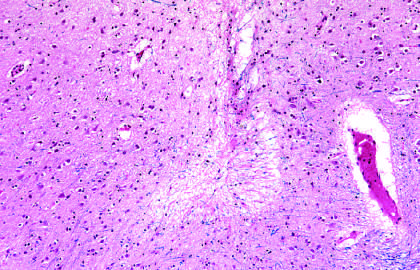re testicular teratomas seen as areas of tissue loss and residual gliosis?
Answer the question using a single word or phrase. No 